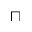<formula> <loc_0><loc_0><loc_500><loc_500>\sqcap</formula> 